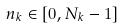<formula> <loc_0><loc_0><loc_500><loc_500>n _ { k } \in [ 0 , N _ { k } - 1 ]</formula> 